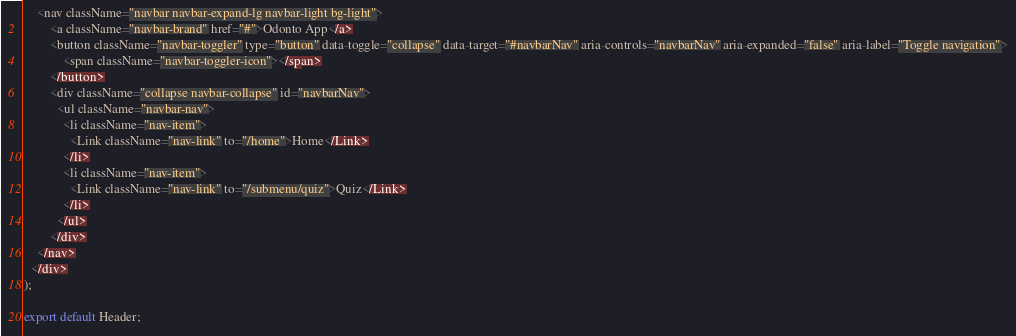<code> <loc_0><loc_0><loc_500><loc_500><_JavaScript_>    <nav className="navbar navbar-expand-lg navbar-light bg-light">
        <a className="navbar-brand" href="#">Odonto App</a>
        <button className="navbar-toggler" type="button" data-toggle="collapse" data-target="#navbarNav" aria-controls="navbarNav" aria-expanded="false" aria-label="Toggle navigation">
            <span className="navbar-toggler-icon"></span>
        </button>
        <div className="collapse navbar-collapse" id="navbarNav">
          <ul className="navbar-nav">
            <li className="nav-item">
              <Link className="nav-link" to="/home">Home</Link>
            </li>
            <li className="nav-item">
              <Link className="nav-link" to="/submenu/quiz">Quiz</Link>
            </li>
          </ul>
        </div>
    </nav>
  </div>
);

export default Header;
</code> 